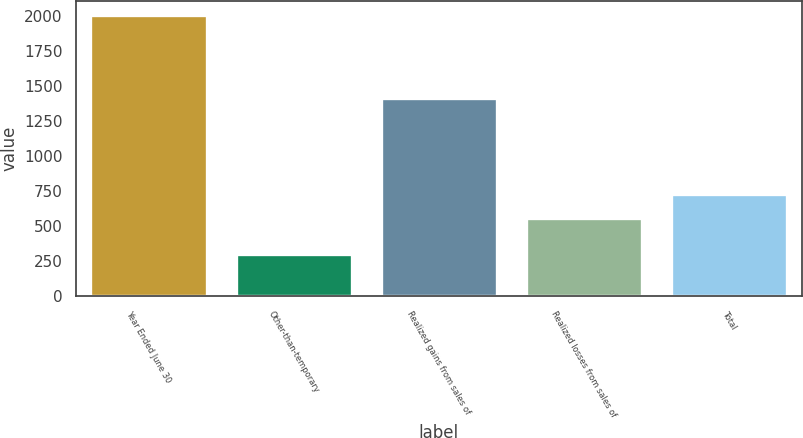<chart> <loc_0><loc_0><loc_500><loc_500><bar_chart><fcel>Year Ended June 30<fcel>Other-than-temporary<fcel>Realized gains from sales of<fcel>Realized losses from sales of<fcel>Total<nl><fcel>2012<fcel>298<fcel>1418<fcel>556<fcel>727.4<nl></chart> 